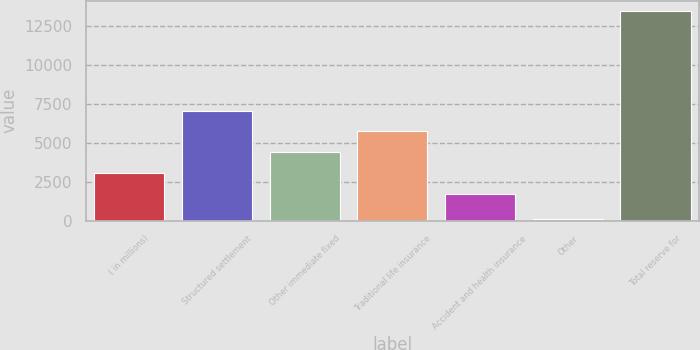Convert chart to OTSL. <chart><loc_0><loc_0><loc_500><loc_500><bar_chart><fcel>( in millions)<fcel>Structured settlement<fcel>Other immediate fixed<fcel>Traditional life insurance<fcel>Accident and health insurance<fcel>Other<fcel>Total reserve for<nl><fcel>3059.5<fcel>7078<fcel>4399<fcel>5738.5<fcel>1720<fcel>87<fcel>13482<nl></chart> 